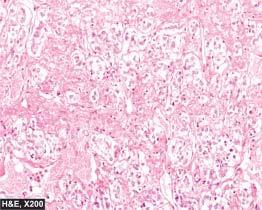how are the tumour cells?
Answer the question using a single word or phrase. Large 